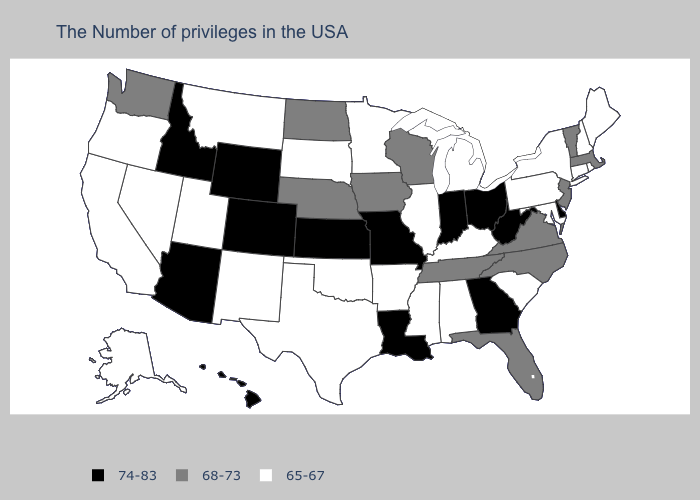Does Oklahoma have the same value as Michigan?
Write a very short answer. Yes. Does New Hampshire have the lowest value in the USA?
Short answer required. Yes. What is the highest value in states that border South Dakota?
Short answer required. 74-83. Name the states that have a value in the range 74-83?
Give a very brief answer. Delaware, West Virginia, Ohio, Georgia, Indiana, Louisiana, Missouri, Kansas, Wyoming, Colorado, Arizona, Idaho, Hawaii. What is the value of New Mexico?
Write a very short answer. 65-67. Among the states that border Virginia , does North Carolina have the lowest value?
Concise answer only. No. Name the states that have a value in the range 74-83?
Concise answer only. Delaware, West Virginia, Ohio, Georgia, Indiana, Louisiana, Missouri, Kansas, Wyoming, Colorado, Arizona, Idaho, Hawaii. What is the highest value in states that border Mississippi?
Quick response, please. 74-83. What is the highest value in the USA?
Quick response, please. 74-83. Name the states that have a value in the range 68-73?
Quick response, please. Massachusetts, Vermont, New Jersey, Virginia, North Carolina, Florida, Tennessee, Wisconsin, Iowa, Nebraska, North Dakota, Washington. Does the map have missing data?
Give a very brief answer. No. What is the value of Arizona?
Quick response, please. 74-83. Among the states that border New Jersey , which have the lowest value?
Be succinct. New York, Pennsylvania. Which states have the lowest value in the Northeast?
Write a very short answer. Maine, Rhode Island, New Hampshire, Connecticut, New York, Pennsylvania. What is the value of Oregon?
Keep it brief. 65-67. 